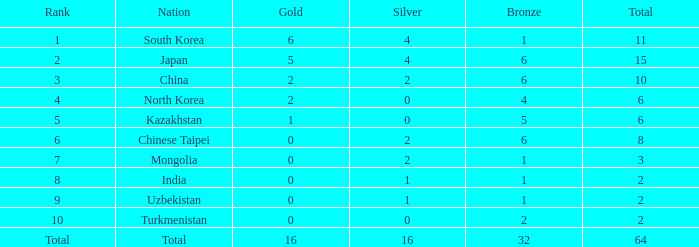What's the biggest Bronze that has less than 0 Silvers? None. 